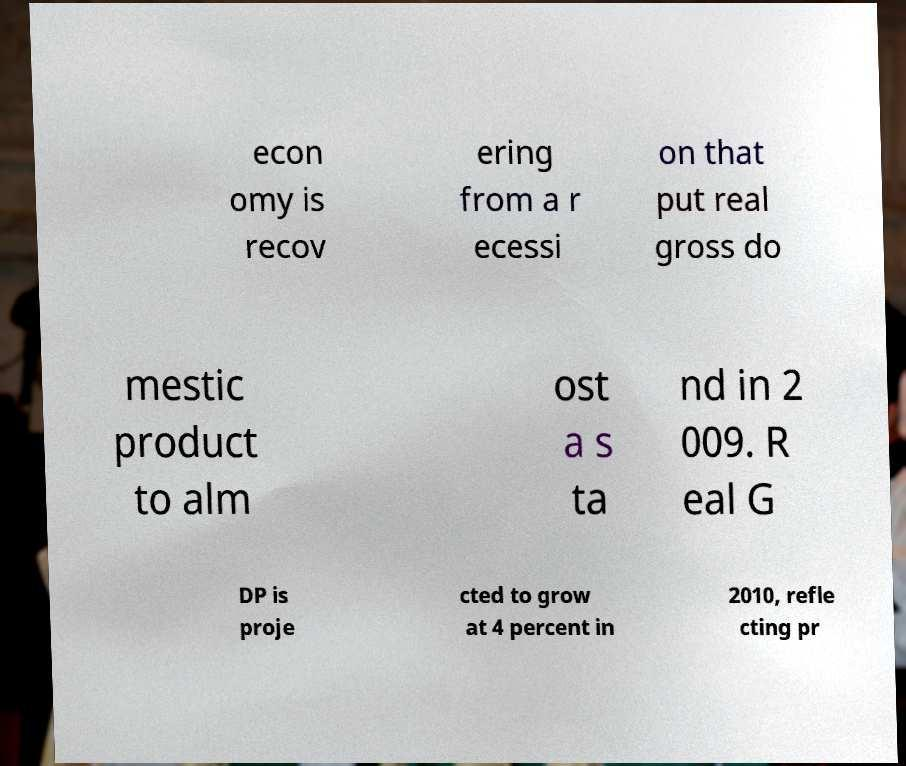Can you accurately transcribe the text from the provided image for me? econ omy is recov ering from a r ecessi on that put real gross do mestic product to alm ost a s ta nd in 2 009. R eal G DP is proje cted to grow at 4 percent in 2010, refle cting pr 